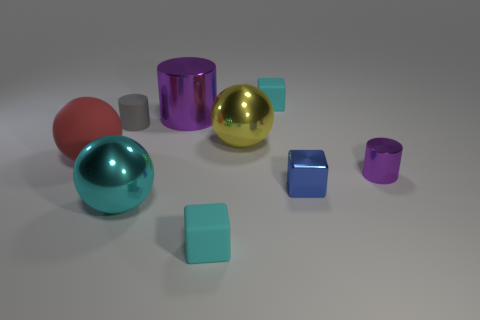Subtract all rubber balls. How many balls are left? 2 Subtract all gray cylinders. How many cyan cubes are left? 2 Add 1 green metallic balls. How many objects exist? 10 Subtract all cubes. How many objects are left? 6 Subtract 1 cylinders. How many cylinders are left? 2 Add 8 large purple cylinders. How many large purple cylinders are left? 9 Add 4 tiny rubber objects. How many tiny rubber objects exist? 7 Subtract 0 green balls. How many objects are left? 9 Subtract all green cylinders. Subtract all gray blocks. How many cylinders are left? 3 Subtract all big brown shiny spheres. Subtract all small rubber blocks. How many objects are left? 7 